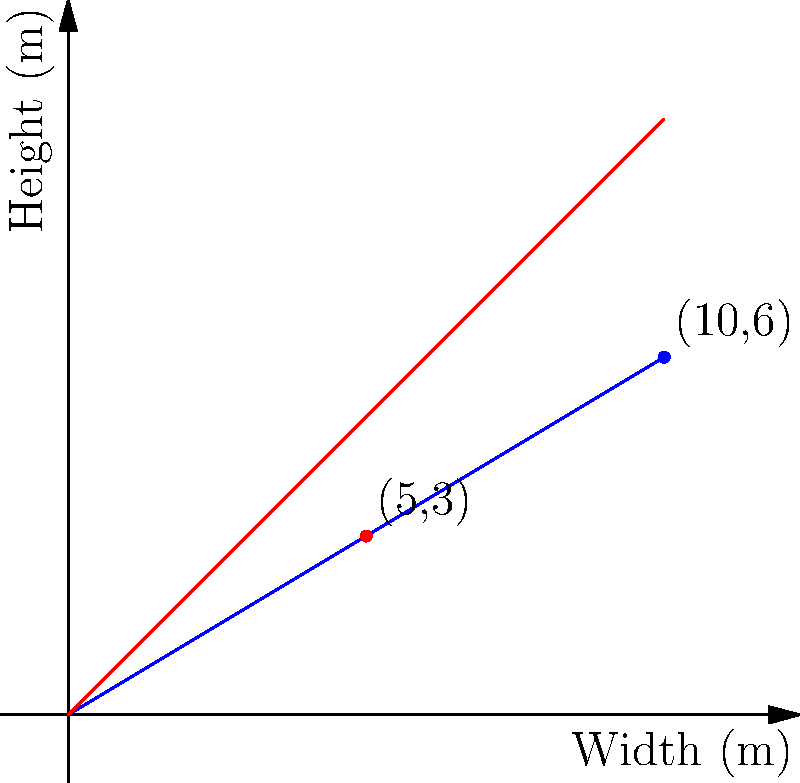The graph shows the relationship between the width and height of a historical building's facade. The blue line represents the facade height, and the red line represents the building width. If the facade follows the principle of the Golden Ratio (approximately 1.618), what should be the height of the facade when the width is 8 meters? Round your answer to the nearest tenth of a meter. To solve this problem, we need to follow these steps:

1) First, we need to understand the Golden Ratio. If we divide the larger dimension by the smaller one, it should equal approximately 1.618.

2) In this case, the width is the larger dimension, and the height is the smaller one. So we can set up the equation:

   $\frac{\text{width}}{\text{height}} = 1.618$

3) We're given that the width is 8 meters. Let's call the height $h$. Substituting these into our equation:

   $\frac{8}{h} = 1.618$

4) To solve for $h$, we can cross-multiply:

   $8 = 1.618h$

5) Now, divide both sides by 1.618:

   $\frac{8}{1.618} = h$

6) Using a calculator (or dividing):

   $h = 4.94495...$ meters

7) Rounding to the nearest tenth as requested:

   $h \approx 4.9$ meters

Therefore, when the width is 8 meters, the height should be approximately 4.9 meters to maintain the Golden Ratio.
Answer: 4.9 meters 